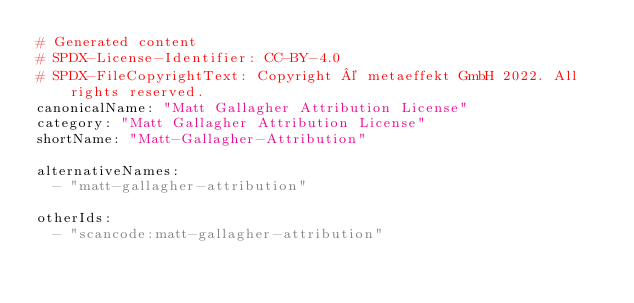Convert code to text. <code><loc_0><loc_0><loc_500><loc_500><_YAML_># Generated content
# SPDX-License-Identifier: CC-BY-4.0
# SPDX-FileCopyrightText: Copyright © metaeffekt GmbH 2022. All rights reserved.
canonicalName: "Matt Gallagher Attribution License"
category: "Matt Gallagher Attribution License"
shortName: "Matt-Gallagher-Attribution"

alternativeNames:
  - "matt-gallagher-attribution"

otherIds: 
  - "scancode:matt-gallagher-attribution"
</code> 